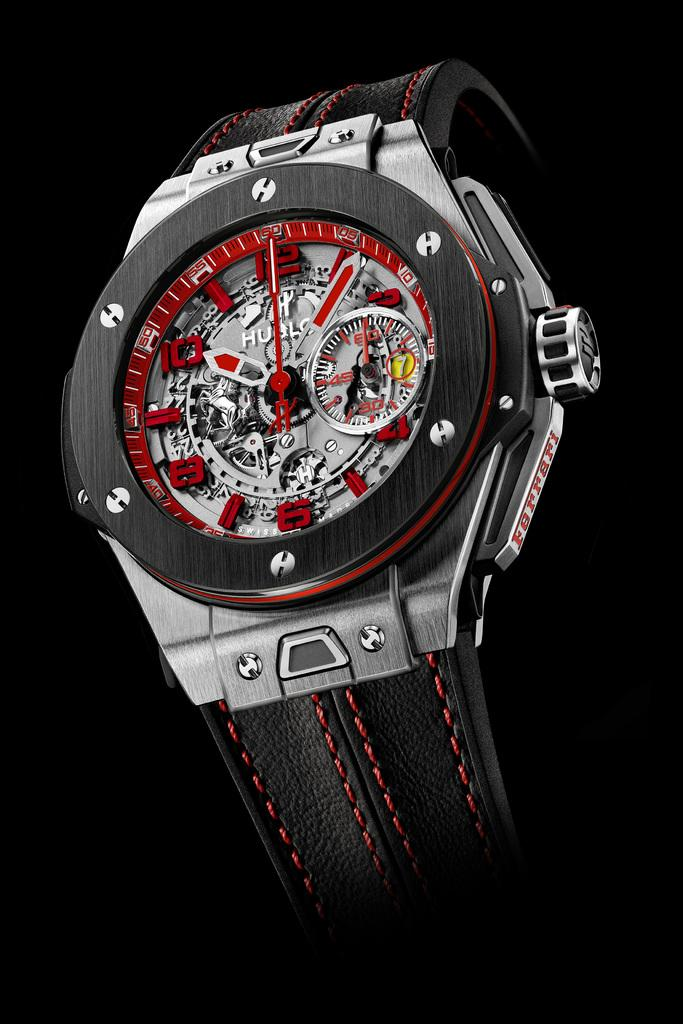<image>
Share a concise interpretation of the image provided. A watch has the brand name Ferrari on the outer edge. 